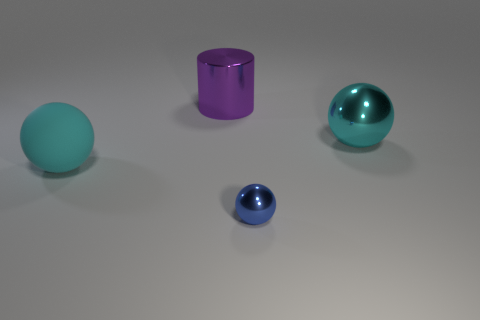Is there a big cyan metallic thing of the same shape as the big cyan rubber object?
Provide a short and direct response. Yes. What is the size of the metallic sphere that is in front of the large cyan ball right of the rubber thing?
Offer a very short reply. Small. There is a thing in front of the big cyan sphere on the left side of the cyan thing on the right side of the purple thing; what shape is it?
Keep it short and to the point. Sphere. What size is the purple thing that is made of the same material as the blue thing?
Offer a very short reply. Large. Are there more small cyan shiny things than large objects?
Make the answer very short. No. What material is the other ball that is the same size as the matte ball?
Keep it short and to the point. Metal. Is the size of the object that is on the right side of the blue thing the same as the cylinder?
Offer a terse response. Yes. How many balls are either big objects or blue things?
Your answer should be compact. 3. There is a cyan ball to the left of the big cyan metal thing; what is it made of?
Your response must be concise. Rubber. Are there fewer big cyan rubber things than brown metallic balls?
Make the answer very short. No. 